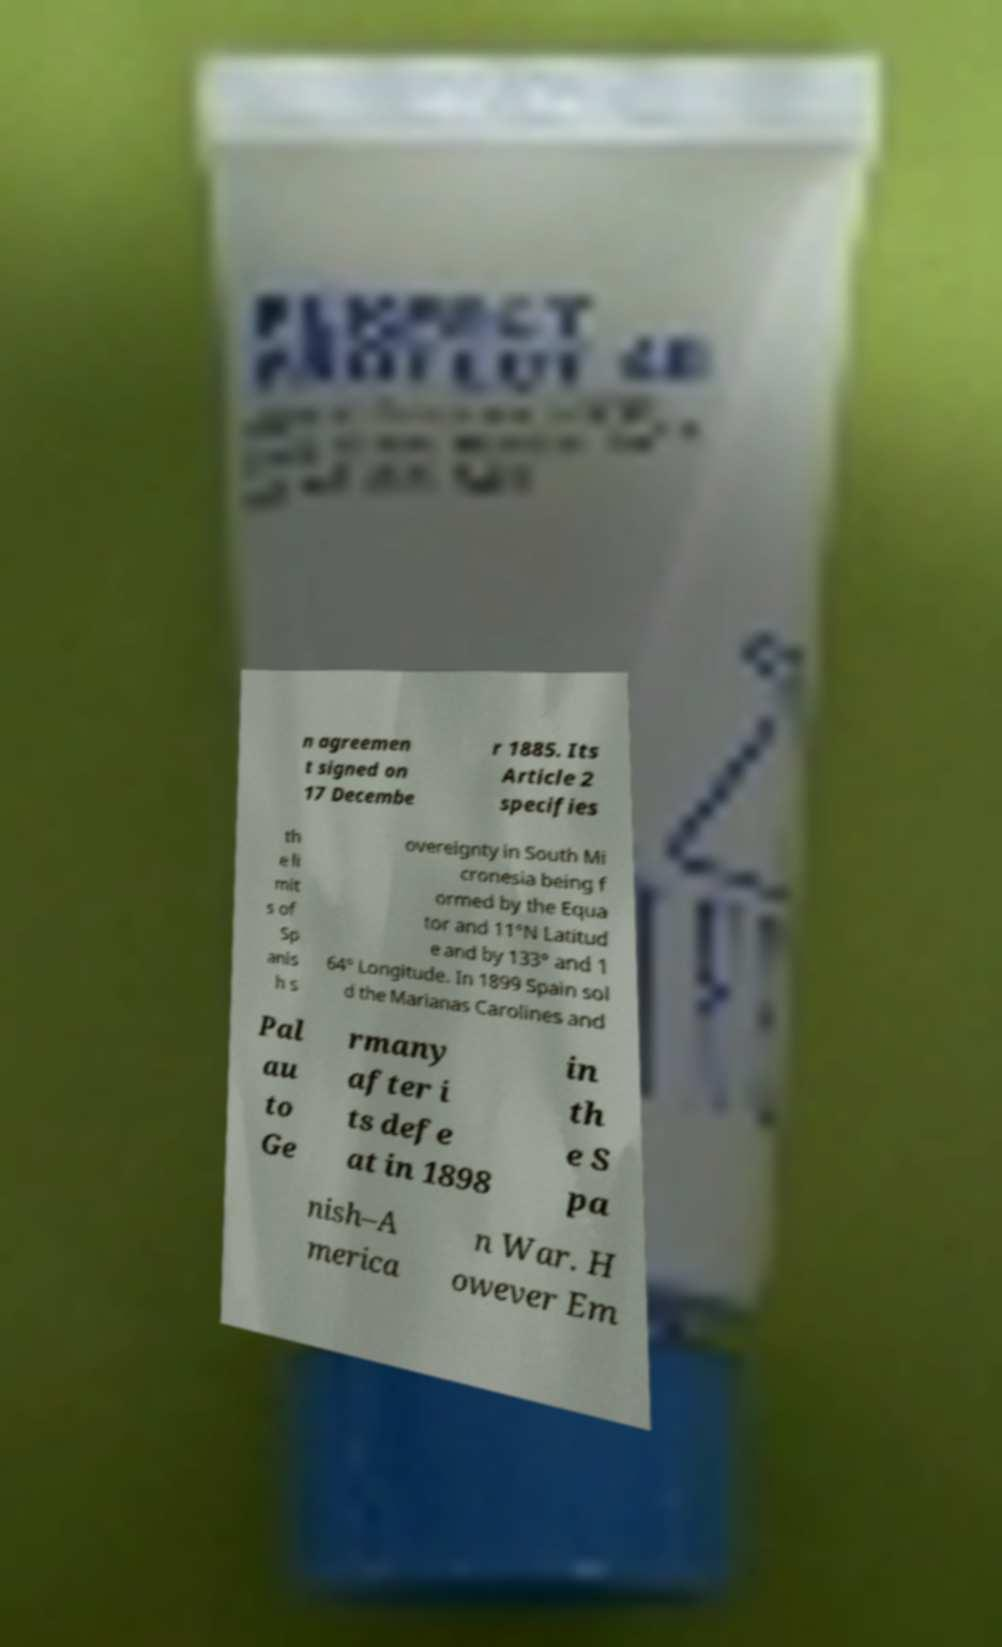Can you read and provide the text displayed in the image?This photo seems to have some interesting text. Can you extract and type it out for me? n agreemen t signed on 17 Decembe r 1885. Its Article 2 specifies th e li mit s of Sp anis h s overeignty in South Mi cronesia being f ormed by the Equa tor and 11°N Latitud e and by 133° and 1 64° Longitude. In 1899 Spain sol d the Marianas Carolines and Pal au to Ge rmany after i ts defe at in 1898 in th e S pa nish–A merica n War. H owever Em 